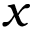<formula> <loc_0><loc_0><loc_500><loc_500>x</formula> 